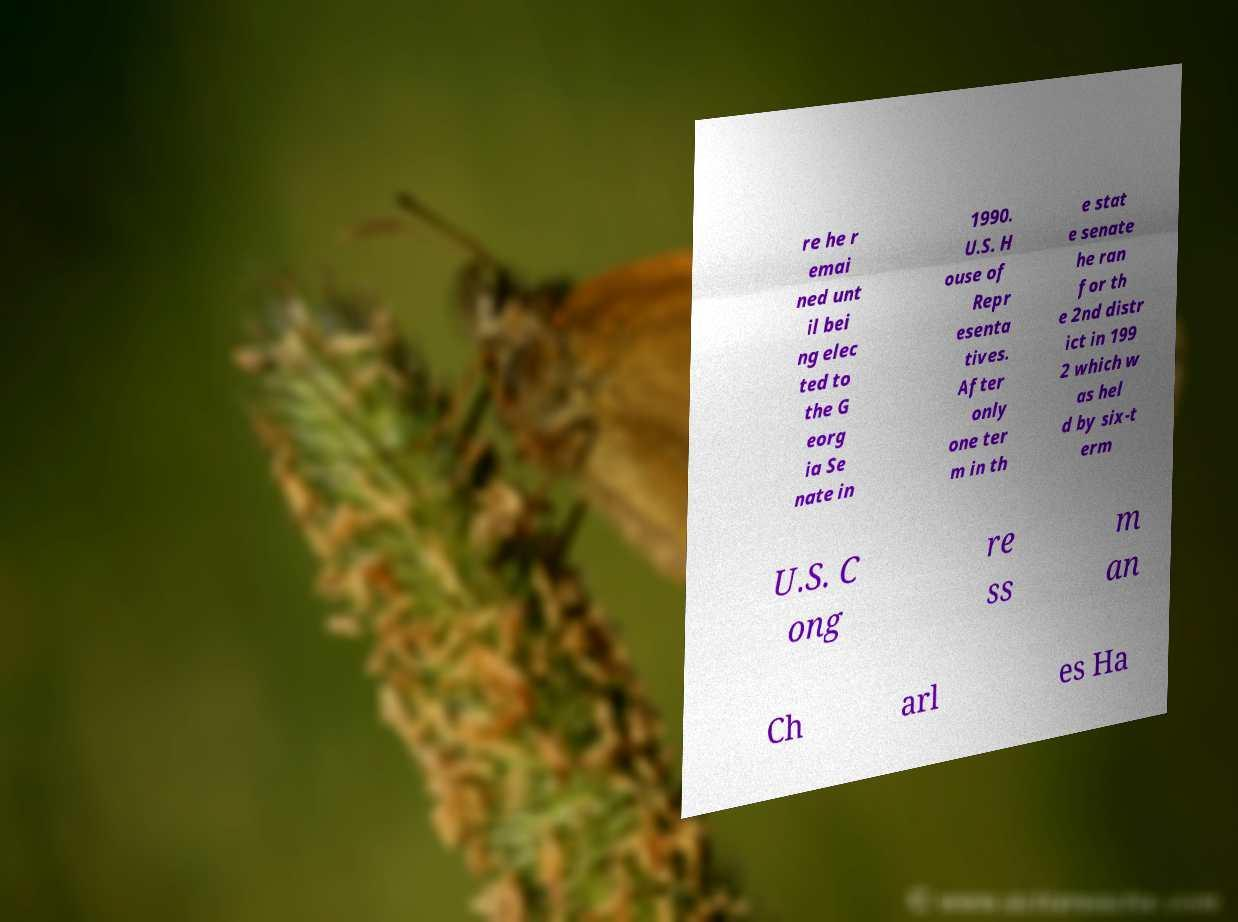Could you extract and type out the text from this image? re he r emai ned unt il bei ng elec ted to the G eorg ia Se nate in 1990. U.S. H ouse of Repr esenta tives. After only one ter m in th e stat e senate he ran for th e 2nd distr ict in 199 2 which w as hel d by six-t erm U.S. C ong re ss m an Ch arl es Ha 